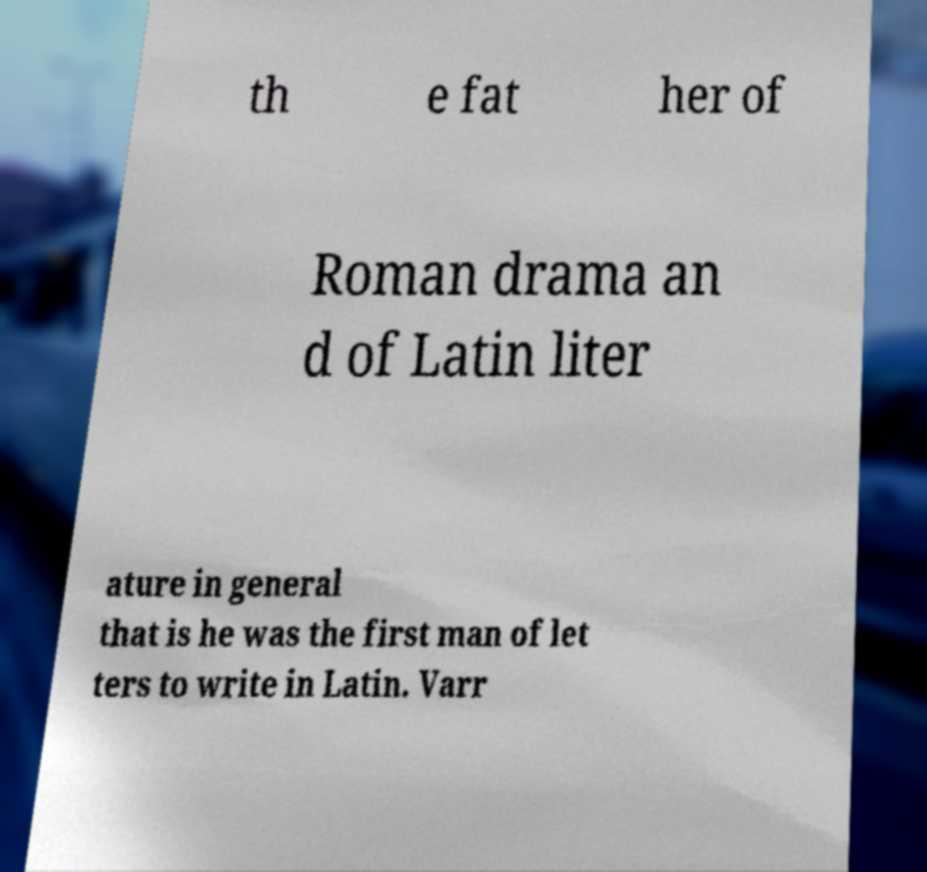Can you read and provide the text displayed in the image?This photo seems to have some interesting text. Can you extract and type it out for me? th e fat her of Roman drama an d of Latin liter ature in general that is he was the first man of let ters to write in Latin. Varr 